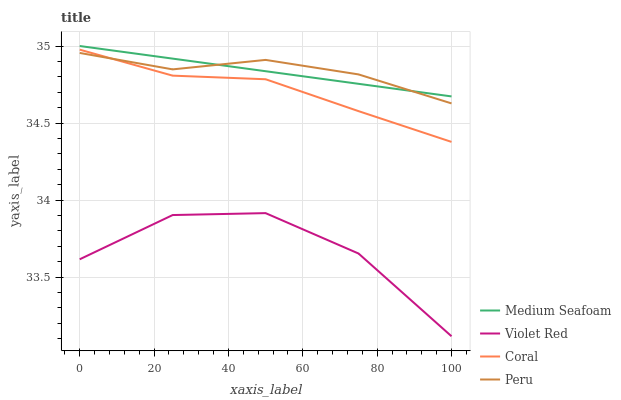Does Violet Red have the minimum area under the curve?
Answer yes or no. Yes. Does Peru have the maximum area under the curve?
Answer yes or no. Yes. Does Medium Seafoam have the minimum area under the curve?
Answer yes or no. No. Does Medium Seafoam have the maximum area under the curve?
Answer yes or no. No. Is Medium Seafoam the smoothest?
Answer yes or no. Yes. Is Violet Red the roughest?
Answer yes or no. Yes. Is Violet Red the smoothest?
Answer yes or no. No. Is Medium Seafoam the roughest?
Answer yes or no. No. Does Violet Red have the lowest value?
Answer yes or no. Yes. Does Medium Seafoam have the lowest value?
Answer yes or no. No. Does Medium Seafoam have the highest value?
Answer yes or no. Yes. Does Violet Red have the highest value?
Answer yes or no. No. Is Violet Red less than Medium Seafoam?
Answer yes or no. Yes. Is Coral greater than Violet Red?
Answer yes or no. Yes. Does Coral intersect Peru?
Answer yes or no. Yes. Is Coral less than Peru?
Answer yes or no. No. Is Coral greater than Peru?
Answer yes or no. No. Does Violet Red intersect Medium Seafoam?
Answer yes or no. No. 